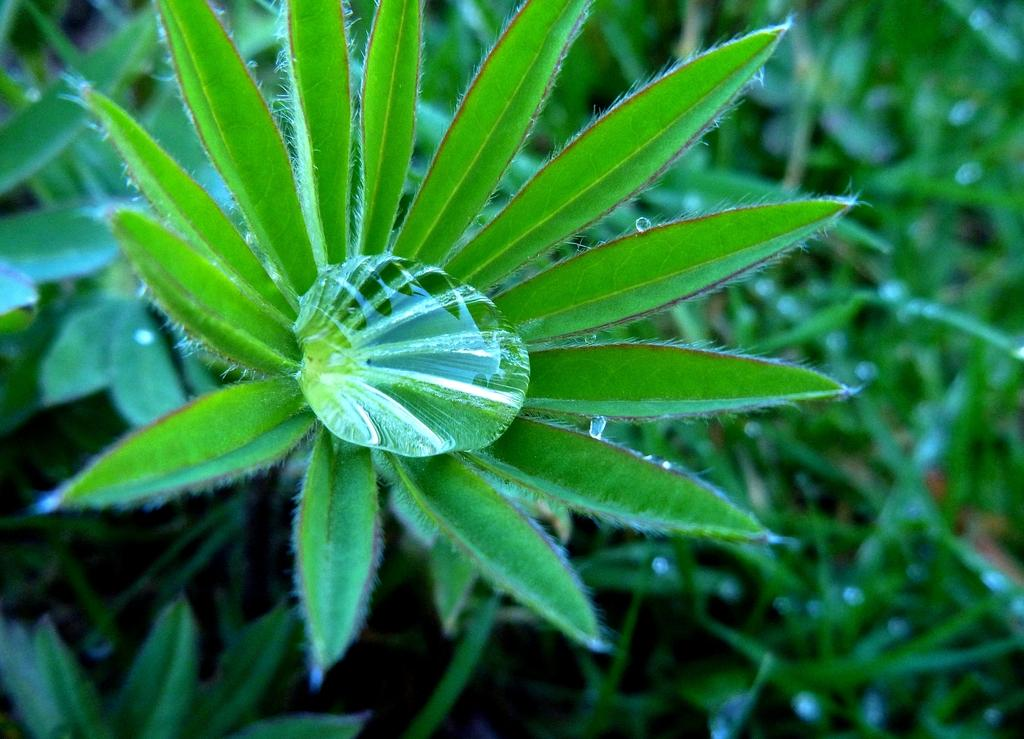What is present on the leaves of the plant in the image? There are water drops on the leaves of the plant in the image. Can you describe the condition of the plant based on the presence of water drops? The presence of water drops suggests that the plant has recently been watered or exposed to moisture. Where is the crown placed on the plant in the image? There is no crown present on the plant in the image. 